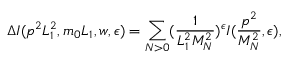Convert formula to latex. <formula><loc_0><loc_0><loc_500><loc_500>\Delta I ( p ^ { 2 } L _ { 1 } ^ { 2 } , m _ { 0 } L _ { 1 } , w , \epsilon ) = \sum _ { N > 0 } ( \frac { 1 } { L _ { 1 } ^ { 2 } M _ { N } ^ { 2 } } ) ^ { \epsilon } I ( \frac { p ^ { 2 } } { M _ { N } ^ { 2 } } , \epsilon ) ,</formula> 